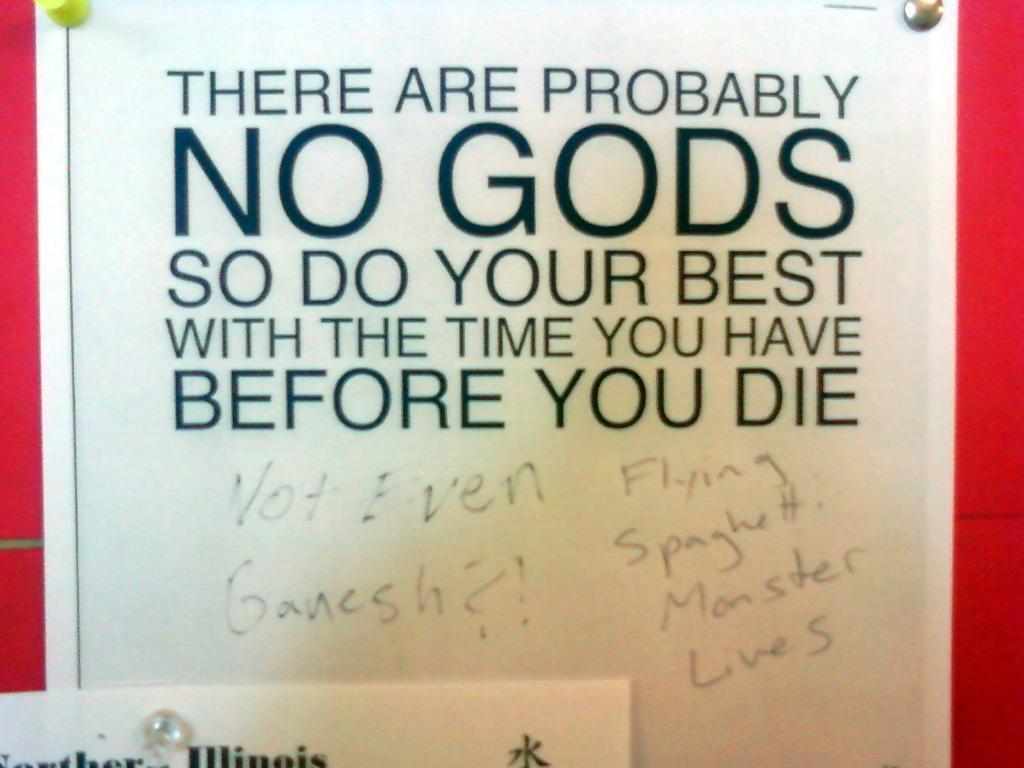Provide a one-sentence caption for the provided image. A bulletin sign that says there are probably no gods. 